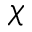Convert formula to latex. <formula><loc_0><loc_0><loc_500><loc_500>\chi</formula> 